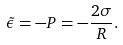<formula> <loc_0><loc_0><loc_500><loc_500>\tilde { \epsilon } = - P = - \frac { 2 \sigma } { R } .</formula> 